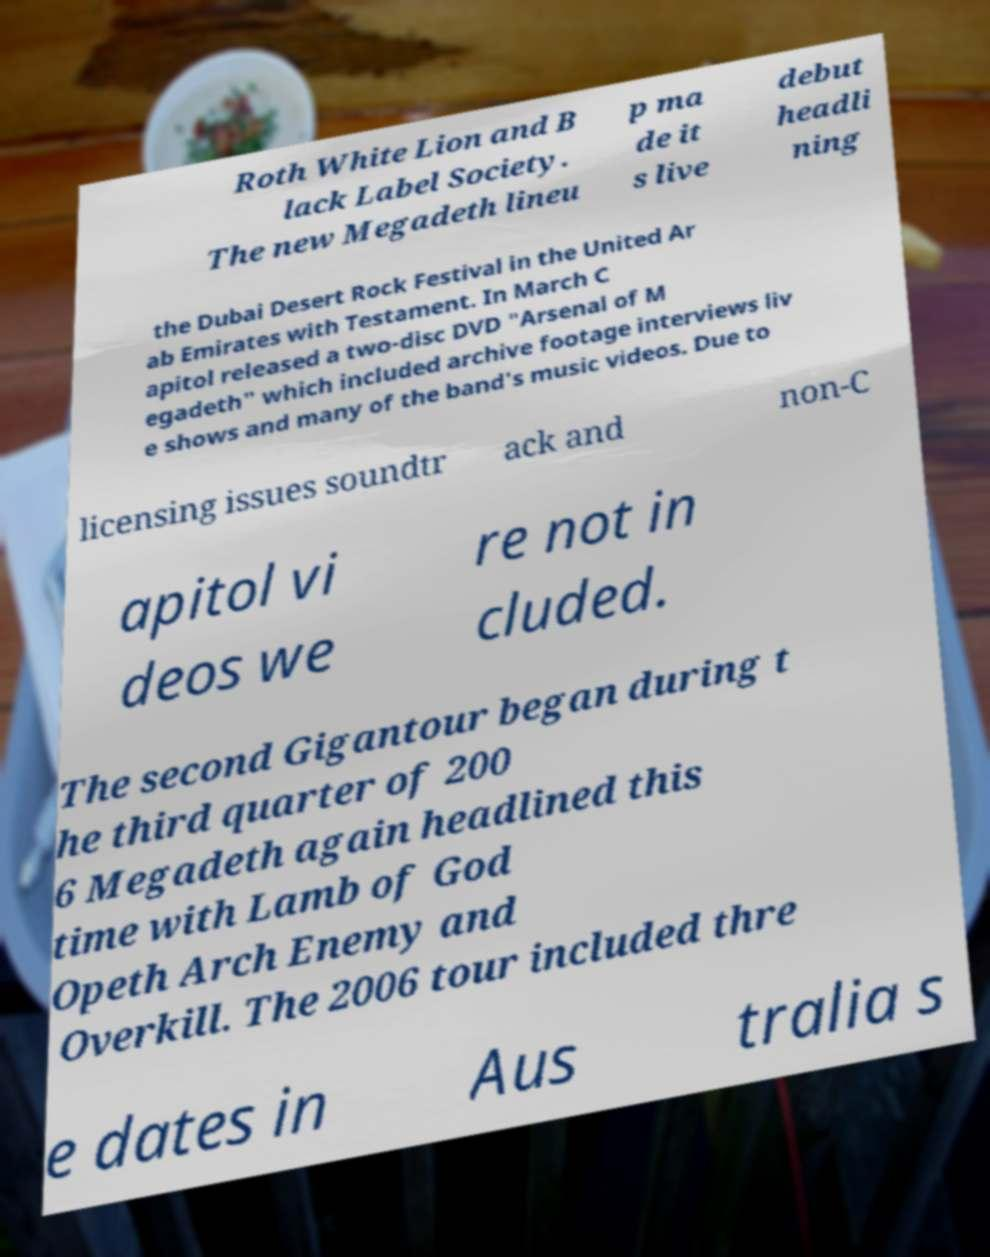What messages or text are displayed in this image? I need them in a readable, typed format. Roth White Lion and B lack Label Society. The new Megadeth lineu p ma de it s live debut headli ning the Dubai Desert Rock Festival in the United Ar ab Emirates with Testament. In March C apitol released a two-disc DVD "Arsenal of M egadeth" which included archive footage interviews liv e shows and many of the band's music videos. Due to licensing issues soundtr ack and non-C apitol vi deos we re not in cluded. The second Gigantour began during t he third quarter of 200 6 Megadeth again headlined this time with Lamb of God Opeth Arch Enemy and Overkill. The 2006 tour included thre e dates in Aus tralia s 